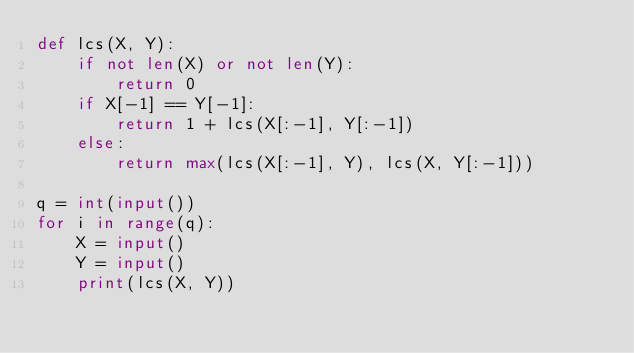<code> <loc_0><loc_0><loc_500><loc_500><_Python_>def lcs(X, Y):
    if not len(X) or not len(Y):
        return 0
    if X[-1] == Y[-1]:
        return 1 + lcs(X[:-1], Y[:-1])
    else:
        return max(lcs(X[:-1], Y), lcs(X, Y[:-1]))

q = int(input())
for i in range(q):
    X = input()
    Y = input()
    print(lcs(X, Y))</code> 